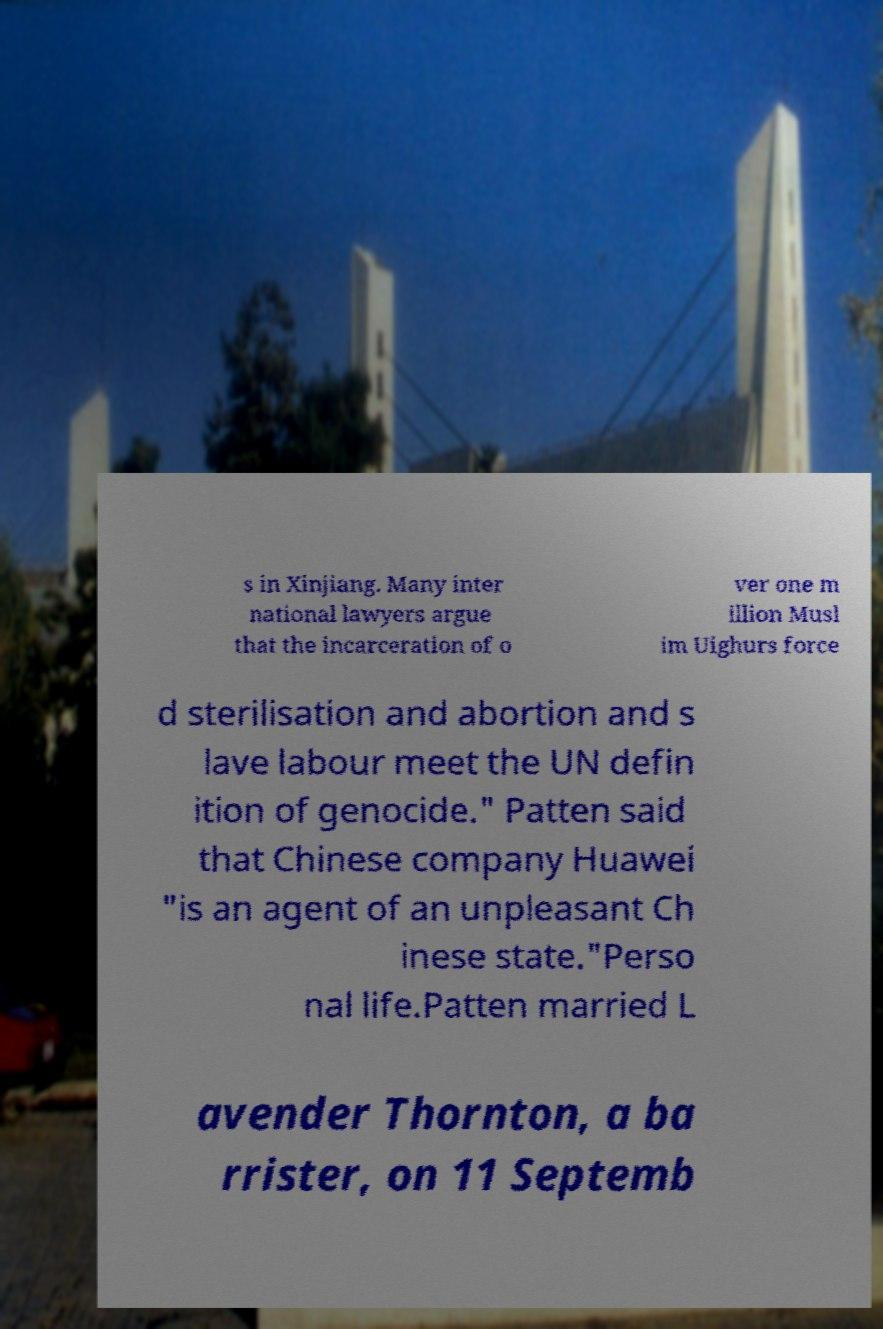Please identify and transcribe the text found in this image. s in Xinjiang. Many inter national lawyers argue that the incarceration of o ver one m illion Musl im Uighurs force d sterilisation and abortion and s lave labour meet the UN defin ition of genocide." Patten said that Chinese company Huawei "is an agent of an unpleasant Ch inese state."Perso nal life.Patten married L avender Thornton, a ba rrister, on 11 Septemb 